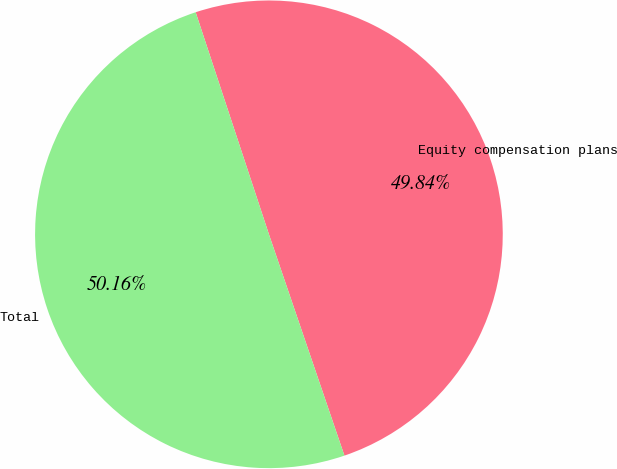<chart> <loc_0><loc_0><loc_500><loc_500><pie_chart><fcel>Equity compensation plans<fcel>Total<nl><fcel>49.84%<fcel>50.16%<nl></chart> 